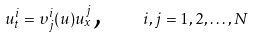<formula> <loc_0><loc_0><loc_500><loc_500>u _ { t } ^ { i } = \upsilon _ { j } ^ { i } ( u ) u _ { x } ^ { j } \text {, \quad } i , j = 1 , 2 , \dots , N</formula> 